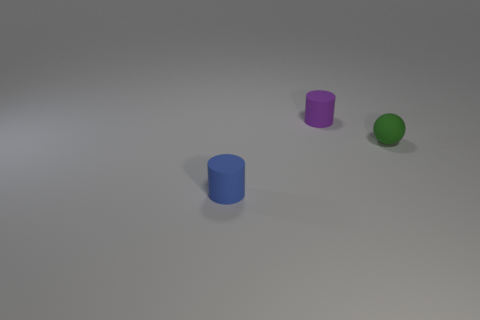What is the color of the other cylinder that is the same material as the small purple cylinder?
Make the answer very short. Blue. What is the material of the cylinder behind the tiny blue object?
Offer a very short reply. Rubber. Do the green object and the thing that is in front of the sphere have the same shape?
Offer a terse response. No. The object that is behind the blue matte cylinder and to the left of the rubber ball is made of what material?
Make the answer very short. Rubber. What color is the other cylinder that is the same size as the purple matte cylinder?
Your answer should be compact. Blue. Is the material of the ball the same as the tiny cylinder in front of the small matte ball?
Your answer should be compact. Yes. What number of other objects are the same size as the purple cylinder?
Make the answer very short. 2. There is a cylinder behind the cylinder that is left of the purple rubber thing; are there any things that are to the left of it?
Provide a short and direct response. Yes. What size is the purple object?
Offer a very short reply. Small. What size is the matte cylinder in front of the purple rubber thing?
Your response must be concise. Small. 